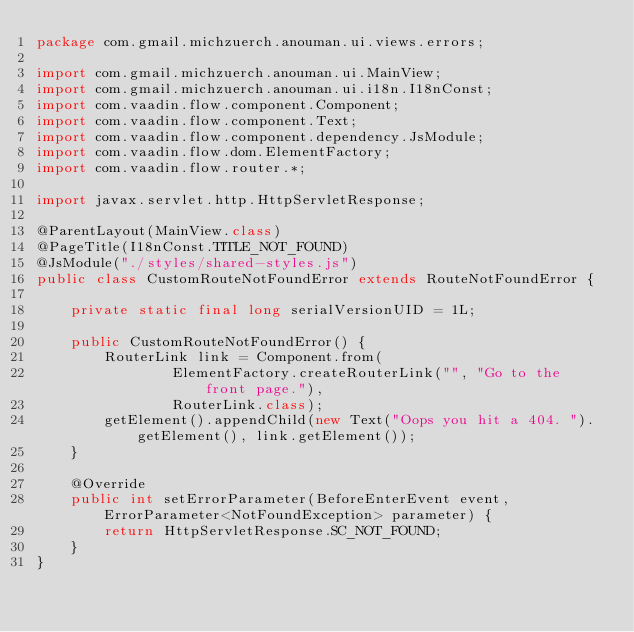Convert code to text. <code><loc_0><loc_0><loc_500><loc_500><_Java_>package com.gmail.michzuerch.anouman.ui.views.errors;

import com.gmail.michzuerch.anouman.ui.MainView;
import com.gmail.michzuerch.anouman.ui.i18n.I18nConst;
import com.vaadin.flow.component.Component;
import com.vaadin.flow.component.Text;
import com.vaadin.flow.component.dependency.JsModule;
import com.vaadin.flow.dom.ElementFactory;
import com.vaadin.flow.router.*;

import javax.servlet.http.HttpServletResponse;

@ParentLayout(MainView.class)
@PageTitle(I18nConst.TITLE_NOT_FOUND)
@JsModule("./styles/shared-styles.js")
public class CustomRouteNotFoundError extends RouteNotFoundError {

    private static final long serialVersionUID = 1L;

    public CustomRouteNotFoundError() {
        RouterLink link = Component.from(
                ElementFactory.createRouterLink("", "Go to the front page."),
                RouterLink.class);
        getElement().appendChild(new Text("Oops you hit a 404. ").getElement(), link.getElement());
    }

    @Override
    public int setErrorParameter(BeforeEnterEvent event, ErrorParameter<NotFoundException> parameter) {
        return HttpServletResponse.SC_NOT_FOUND;
    }
}
</code> 